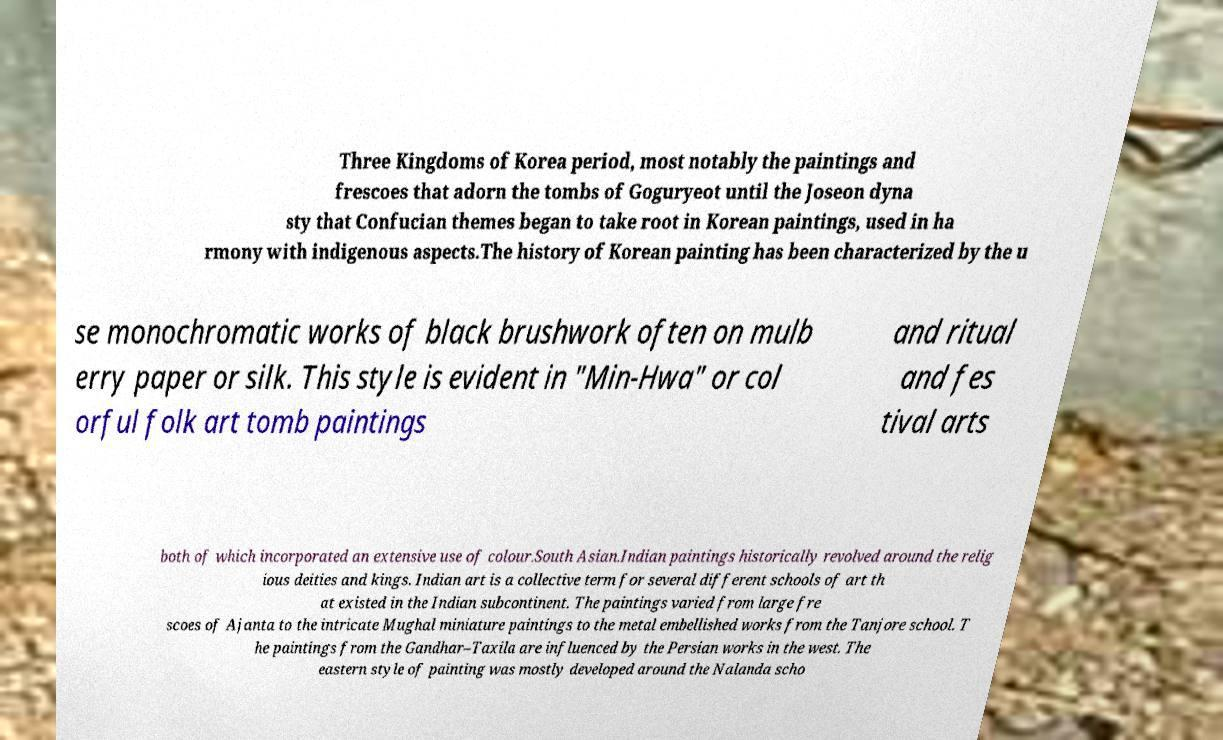There's text embedded in this image that I need extracted. Can you transcribe it verbatim? Three Kingdoms of Korea period, most notably the paintings and frescoes that adorn the tombs of Goguryeot until the Joseon dyna sty that Confucian themes began to take root in Korean paintings, used in ha rmony with indigenous aspects.The history of Korean painting has been characterized by the u se monochromatic works of black brushwork often on mulb erry paper or silk. This style is evident in "Min-Hwa" or col orful folk art tomb paintings and ritual and fes tival arts both of which incorporated an extensive use of colour.South Asian.Indian paintings historically revolved around the relig ious deities and kings. Indian art is a collective term for several different schools of art th at existed in the Indian subcontinent. The paintings varied from large fre scoes of Ajanta to the intricate Mughal miniature paintings to the metal embellished works from the Tanjore school. T he paintings from the Gandhar–Taxila are influenced by the Persian works in the west. The eastern style of painting was mostly developed around the Nalanda scho 